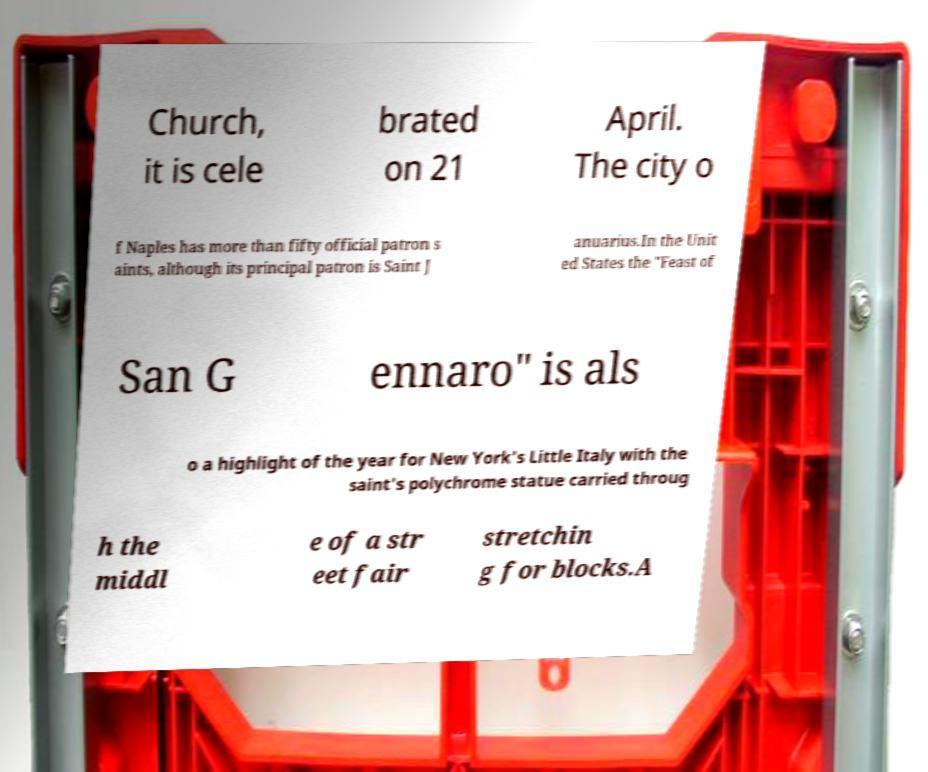For documentation purposes, I need the text within this image transcribed. Could you provide that? Church, it is cele brated on 21 April. The city o f Naples has more than fifty official patron s aints, although its principal patron is Saint J anuarius.In the Unit ed States the "Feast of San G ennaro" is als o a highlight of the year for New York's Little Italy with the saint's polychrome statue carried throug h the middl e of a str eet fair stretchin g for blocks.A 